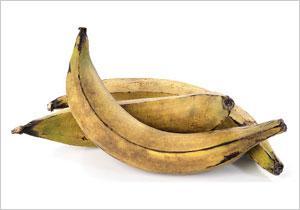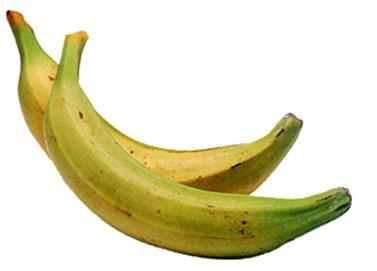The first image is the image on the left, the second image is the image on the right. Evaluate the accuracy of this statement regarding the images: "The left image contains a banana bunch with stems connected, and the right image includes at least part of an exposed, unpeeled banana.". Is it true? Answer yes or no. No. The first image is the image on the left, the second image is the image on the right. Examine the images to the left and right. Is the description "In one of the images, at least part of a banana has been cut into slices." accurate? Answer yes or no. No. 